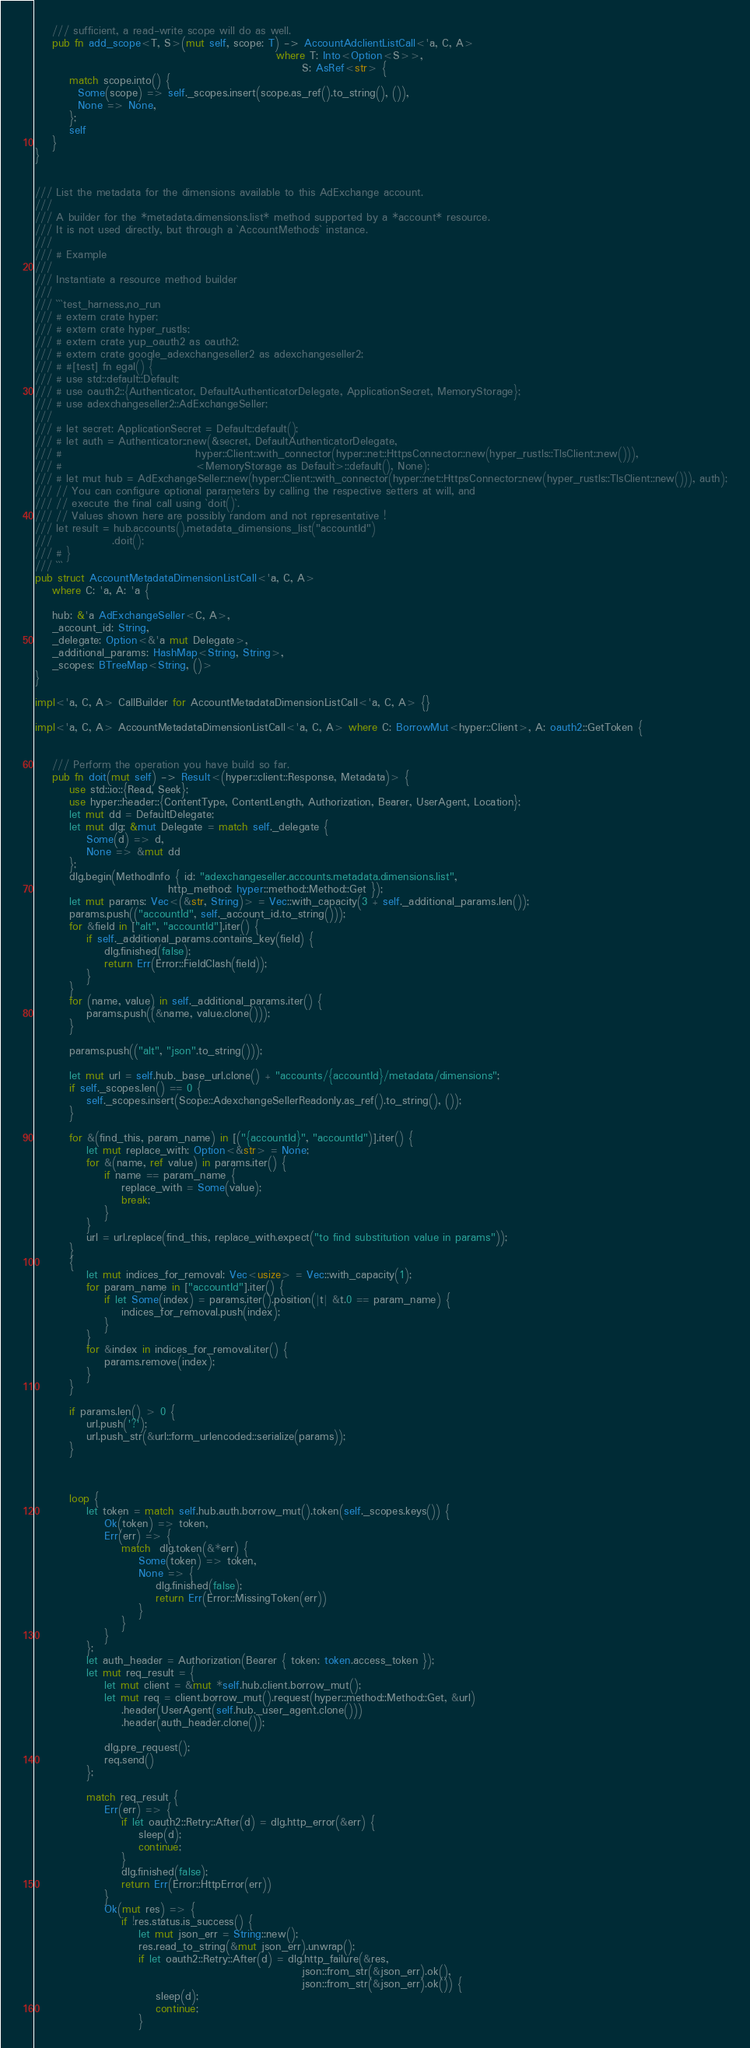<code> <loc_0><loc_0><loc_500><loc_500><_Rust_>    /// sufficient, a read-write scope will do as well.
    pub fn add_scope<T, S>(mut self, scope: T) -> AccountAdclientListCall<'a, C, A>
                                                        where T: Into<Option<S>>,
                                                              S: AsRef<str> {
        match scope.into() {
          Some(scope) => self._scopes.insert(scope.as_ref().to_string(), ()),
          None => None,
        };
        self
    }
}


/// List the metadata for the dimensions available to this AdExchange account.
///
/// A builder for the *metadata.dimensions.list* method supported by a *account* resource.
/// It is not used directly, but through a `AccountMethods` instance.
///
/// # Example
///
/// Instantiate a resource method builder
///
/// ```test_harness,no_run
/// # extern crate hyper;
/// # extern crate hyper_rustls;
/// # extern crate yup_oauth2 as oauth2;
/// # extern crate google_adexchangeseller2 as adexchangeseller2;
/// # #[test] fn egal() {
/// # use std::default::Default;
/// # use oauth2::{Authenticator, DefaultAuthenticatorDelegate, ApplicationSecret, MemoryStorage};
/// # use adexchangeseller2::AdExchangeSeller;
/// 
/// # let secret: ApplicationSecret = Default::default();
/// # let auth = Authenticator::new(&secret, DefaultAuthenticatorDelegate,
/// #                               hyper::Client::with_connector(hyper::net::HttpsConnector::new(hyper_rustls::TlsClient::new())),
/// #                               <MemoryStorage as Default>::default(), None);
/// # let mut hub = AdExchangeSeller::new(hyper::Client::with_connector(hyper::net::HttpsConnector::new(hyper_rustls::TlsClient::new())), auth);
/// // You can configure optional parameters by calling the respective setters at will, and
/// // execute the final call using `doit()`.
/// // Values shown here are possibly random and not representative !
/// let result = hub.accounts().metadata_dimensions_list("accountId")
///              .doit();
/// # }
/// ```
pub struct AccountMetadataDimensionListCall<'a, C, A>
    where C: 'a, A: 'a {

    hub: &'a AdExchangeSeller<C, A>,
    _account_id: String,
    _delegate: Option<&'a mut Delegate>,
    _additional_params: HashMap<String, String>,
    _scopes: BTreeMap<String, ()>
}

impl<'a, C, A> CallBuilder for AccountMetadataDimensionListCall<'a, C, A> {}

impl<'a, C, A> AccountMetadataDimensionListCall<'a, C, A> where C: BorrowMut<hyper::Client>, A: oauth2::GetToken {


    /// Perform the operation you have build so far.
    pub fn doit(mut self) -> Result<(hyper::client::Response, Metadata)> {
        use std::io::{Read, Seek};
        use hyper::header::{ContentType, ContentLength, Authorization, Bearer, UserAgent, Location};
        let mut dd = DefaultDelegate;
        let mut dlg: &mut Delegate = match self._delegate {
            Some(d) => d,
            None => &mut dd
        };
        dlg.begin(MethodInfo { id: "adexchangeseller.accounts.metadata.dimensions.list",
                               http_method: hyper::method::Method::Get });
        let mut params: Vec<(&str, String)> = Vec::with_capacity(3 + self._additional_params.len());
        params.push(("accountId", self._account_id.to_string()));
        for &field in ["alt", "accountId"].iter() {
            if self._additional_params.contains_key(field) {
                dlg.finished(false);
                return Err(Error::FieldClash(field));
            }
        }
        for (name, value) in self._additional_params.iter() {
            params.push((&name, value.clone()));
        }

        params.push(("alt", "json".to_string()));

        let mut url = self.hub._base_url.clone() + "accounts/{accountId}/metadata/dimensions";
        if self._scopes.len() == 0 {
            self._scopes.insert(Scope::AdexchangeSellerReadonly.as_ref().to_string(), ());
        }

        for &(find_this, param_name) in [("{accountId}", "accountId")].iter() {
            let mut replace_with: Option<&str> = None;
            for &(name, ref value) in params.iter() {
                if name == param_name {
                    replace_with = Some(value);
                    break;
                }
            }
            url = url.replace(find_this, replace_with.expect("to find substitution value in params"));
        }
        {
            let mut indices_for_removal: Vec<usize> = Vec::with_capacity(1);
            for param_name in ["accountId"].iter() {
                if let Some(index) = params.iter().position(|t| &t.0 == param_name) {
                    indices_for_removal.push(index);
                }
            }
            for &index in indices_for_removal.iter() {
                params.remove(index);
            }
        }

        if params.len() > 0 {
            url.push('?');
            url.push_str(&url::form_urlencoded::serialize(params));
        }



        loop {
            let token = match self.hub.auth.borrow_mut().token(self._scopes.keys()) {
                Ok(token) => token,
                Err(err) => {
                    match  dlg.token(&*err) {
                        Some(token) => token,
                        None => {
                            dlg.finished(false);
                            return Err(Error::MissingToken(err))
                        }
                    }
                }
            };
            let auth_header = Authorization(Bearer { token: token.access_token });
            let mut req_result = {
                let mut client = &mut *self.hub.client.borrow_mut();
                let mut req = client.borrow_mut().request(hyper::method::Method::Get, &url)
                    .header(UserAgent(self.hub._user_agent.clone()))
                    .header(auth_header.clone());

                dlg.pre_request();
                req.send()
            };

            match req_result {
                Err(err) => {
                    if let oauth2::Retry::After(d) = dlg.http_error(&err) {
                        sleep(d);
                        continue;
                    }
                    dlg.finished(false);
                    return Err(Error::HttpError(err))
                }
                Ok(mut res) => {
                    if !res.status.is_success() {
                        let mut json_err = String::new();
                        res.read_to_string(&mut json_err).unwrap();
                        if let oauth2::Retry::After(d) = dlg.http_failure(&res,
                                                              json::from_str(&json_err).ok(),
                                                              json::from_str(&json_err).ok()) {
                            sleep(d);
                            continue;
                        }</code> 